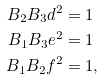Convert formula to latex. <formula><loc_0><loc_0><loc_500><loc_500>B _ { 2 } B _ { 3 } d ^ { 2 } & = 1 \\ B _ { 1 } B _ { 3 } e ^ { 2 } & = 1 \\ B _ { 1 } B _ { 2 } f ^ { 2 } & = 1 ,</formula> 